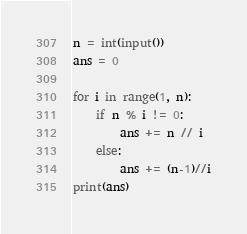Convert code to text. <code><loc_0><loc_0><loc_500><loc_500><_Python_>n = int(input())
ans = 0

for i in range(1, n):
    if n % i != 0:
        ans += n // i
    else:
        ans += (n-1)//i
print(ans)</code> 